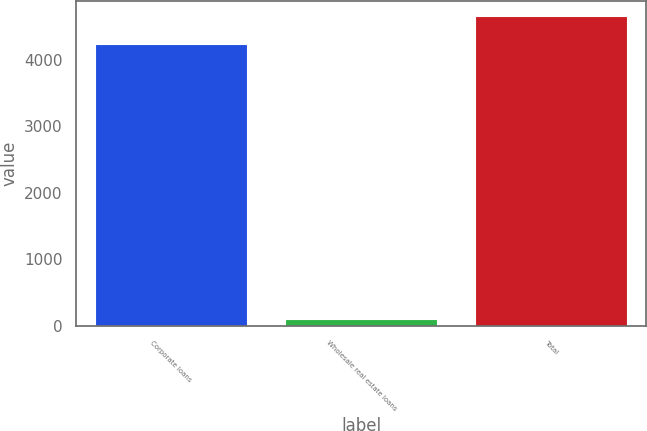Convert chart. <chart><loc_0><loc_0><loc_500><loc_500><bar_chart><fcel>Corporate loans<fcel>Wholesale real estate loans<fcel>Total<nl><fcel>4231<fcel>100<fcel>4654.1<nl></chart> 